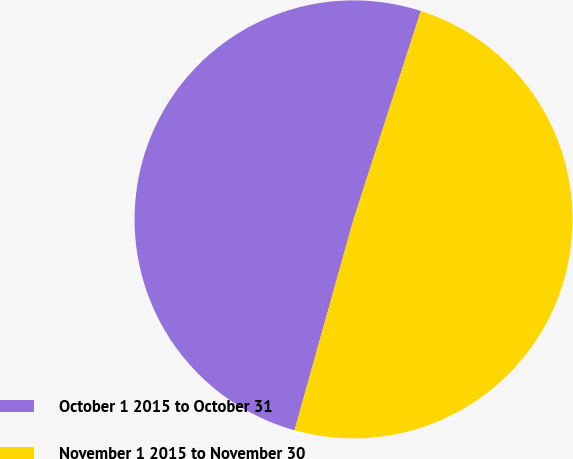Convert chart to OTSL. <chart><loc_0><loc_0><loc_500><loc_500><pie_chart><fcel>October 1 2015 to October 31<fcel>November 1 2015 to November 30<nl><fcel>50.63%<fcel>49.37%<nl></chart> 